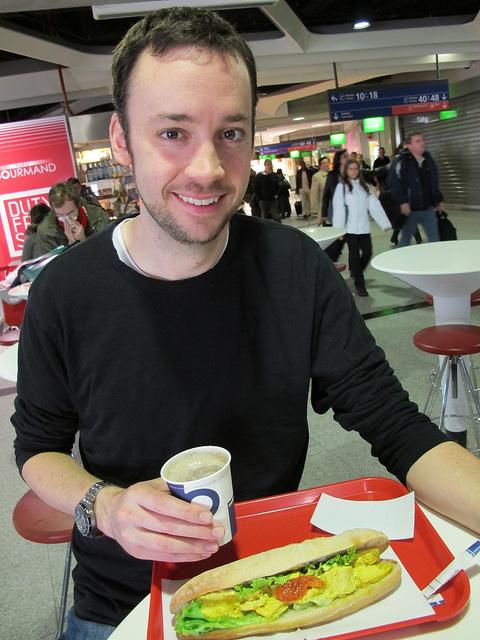Is this a restaurant?
Short answer required. No. What brand of soda is on the cup?
Be succinct. Pepsi. What kind of sandwich is on the tray?
Answer briefly. Sub. Is the man wearing a watch?
Give a very brief answer. Yes. What pattern is on the man's shirt?
Concise answer only. None. 